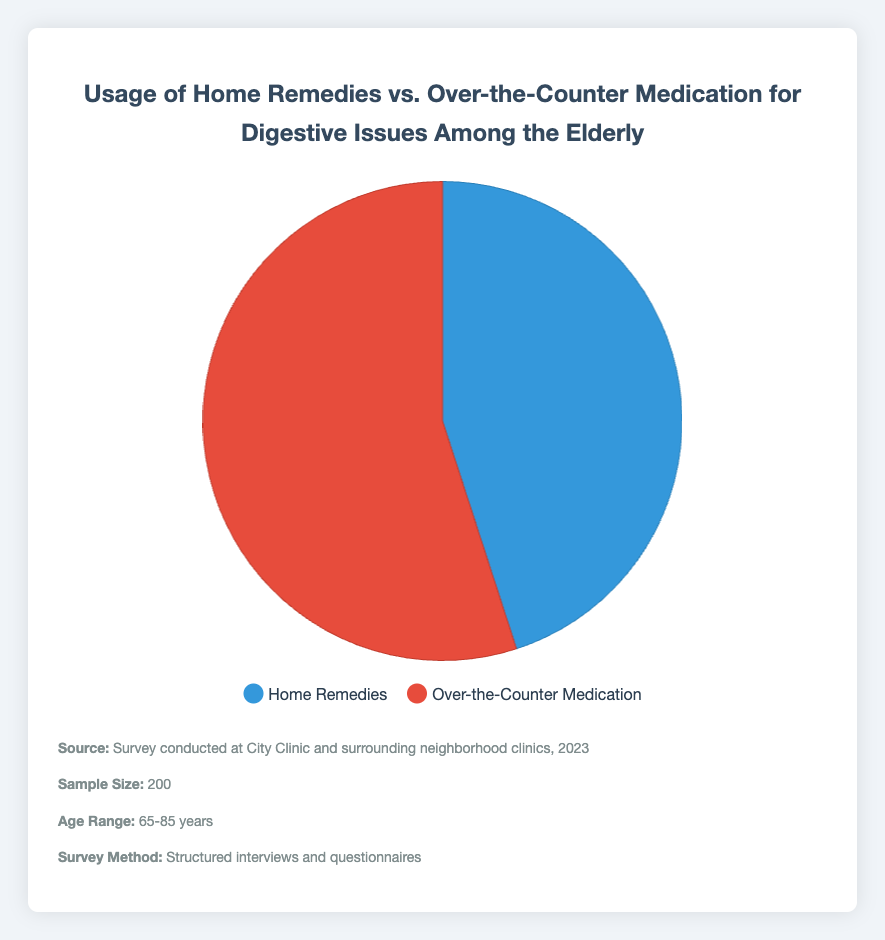How many percentage points more is the usage of Over-the-Counter Medication compared to Home Remedies? The figure shows that Over-the-Counter medication usage is at 55%, and Home Remedies is at 45%. Subtracting the percentage of Home Remedies from Over-the-Counter Medication, we get 55% - 45% = 10%.
Answer: 10% Is the percentage of Over-the-Counter Medication usage higher than Home Remedies? The chart shows two categories: Home Remedies at 45% and Over-the-Counter Medication at 55%. Since 55% is greater than 45%, the usage of Over-the-Counter Medication is higher.
Answer: Yes What would be the combined percentage if both Home Remedies and Over-the-Counter Medication usage were added together? Adding the percentage usage of Home Remedies (45%) and Over-the-Counter Medication (55%) gives us 45% + 55% = 100%.
Answer: 100% Which treatment method has a greater share according to the pie chart? By observing the pie chart, the section labeled Over-the-Counter Medication occupies a larger portion than Home Remedies, indicating its greater share.
Answer: Over-the-Counter Medication How much more in percentage is Over-the-Counter Medication usage compared to Home Remedies if counted per 200 surveyed elderly? First, calculate the percentage difference, which is 10%. Since the sample size is 200, 10% of 200 is 20. Hence, Over-the-Counter Medication is used by 20 more elderly people compared to Home Remedies.
Answer: 20 people What color represents Home Remedies in the pie chart? The legend of the chart indicates that Home Remedies is represented by the color blue.
Answer: Blue Which treatment method has more respondents, Home Remedies or Over-the-Counter Medication? The pie chart indicates that Over-the-Counter Medication is used by 55% of the respondents while Home Remedies is used by 45%. Since 55% is greater than 45%, Over-the-Counter Medication has more respondents.
Answer: Over-the-Counter Medication What is the proportion of elderly choosing Home Remedies versus those choosing Over-the-Counter Medication? The pie chart shows Home Remedies at 45% and Over-the-Counter Medication at 55%. Therefore, the proportion of elderly using Home Remedies to Over-the-Counter Medication is 45:55.
Answer: 45:55 Subtract the percentage of Home Remedies users from Over-the-Counter Medication users. According to the figure, Home Remedies users are 45% while Over-the-Counter Medication users are 55%. Subtracting these values, 55% - 45% = 10%.
Answer: 10% If the sample size is 200, how many elderly are using each method? For Home Remedies: 45% of 200 => 0.45 * 200 = 90. For Over-the-Counter Medication: 55% of 200 => 0.55 * 200 = 110.
Answer: 90 for Home Remedies, 110 for Over-the-Counter Medication 